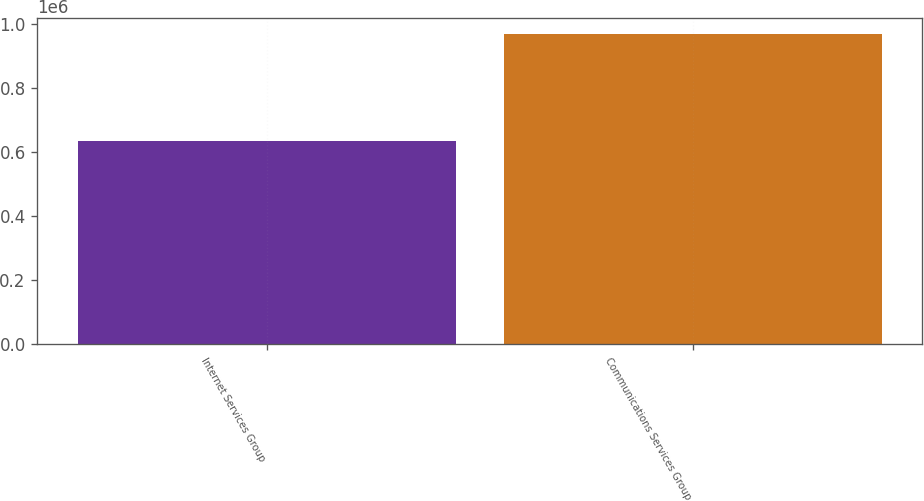<chart> <loc_0><loc_0><loc_500><loc_500><bar_chart><fcel>Internet Services Group<fcel>Communications Services Group<nl><fcel>633784<fcel>970793<nl></chart> 